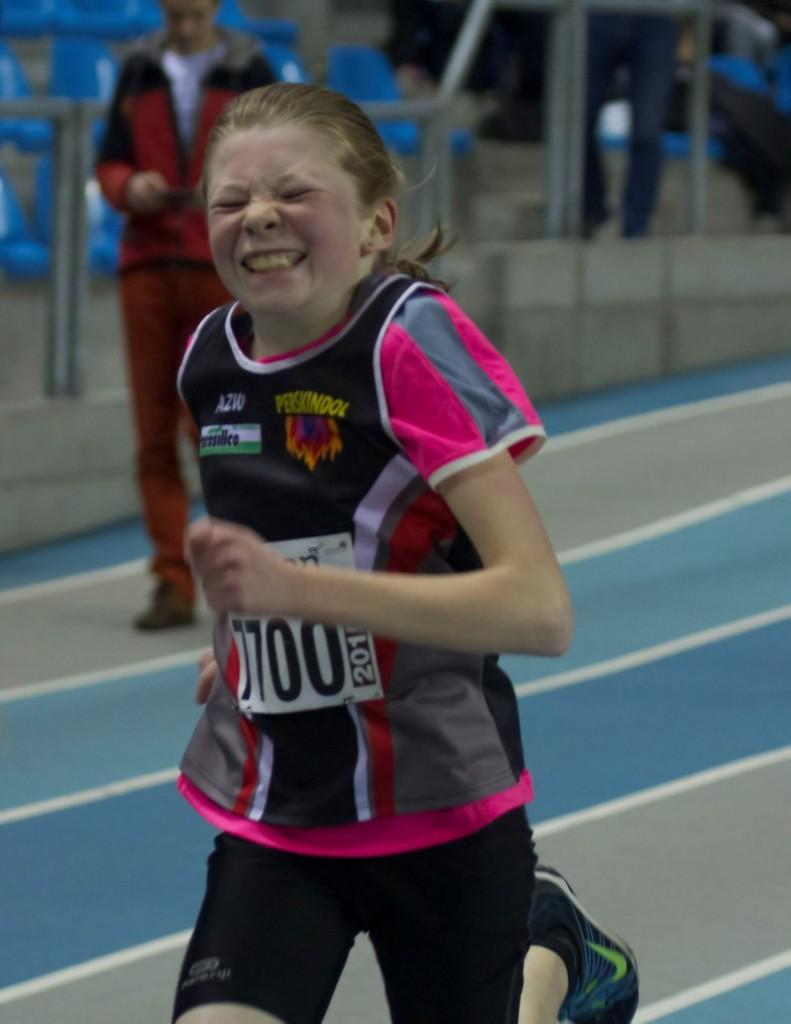What is the girl in the image doing? The girl is running in the image. What activity is the girl participating in? The girl is participating in a race. Who else is present in the image? There is a man standing in the image. What is the man holding? The man is holding an object. What can be seen in the background of the image? Chairs, poles, and other objects are visible in the background of the image. What type of plants can be seen growing on the girl's finger in the image? There are no plants visible on the girl's finger in the image. What type of cast is visible on the man's arm in the image? There is no cast visible on the man's arm in the image. 